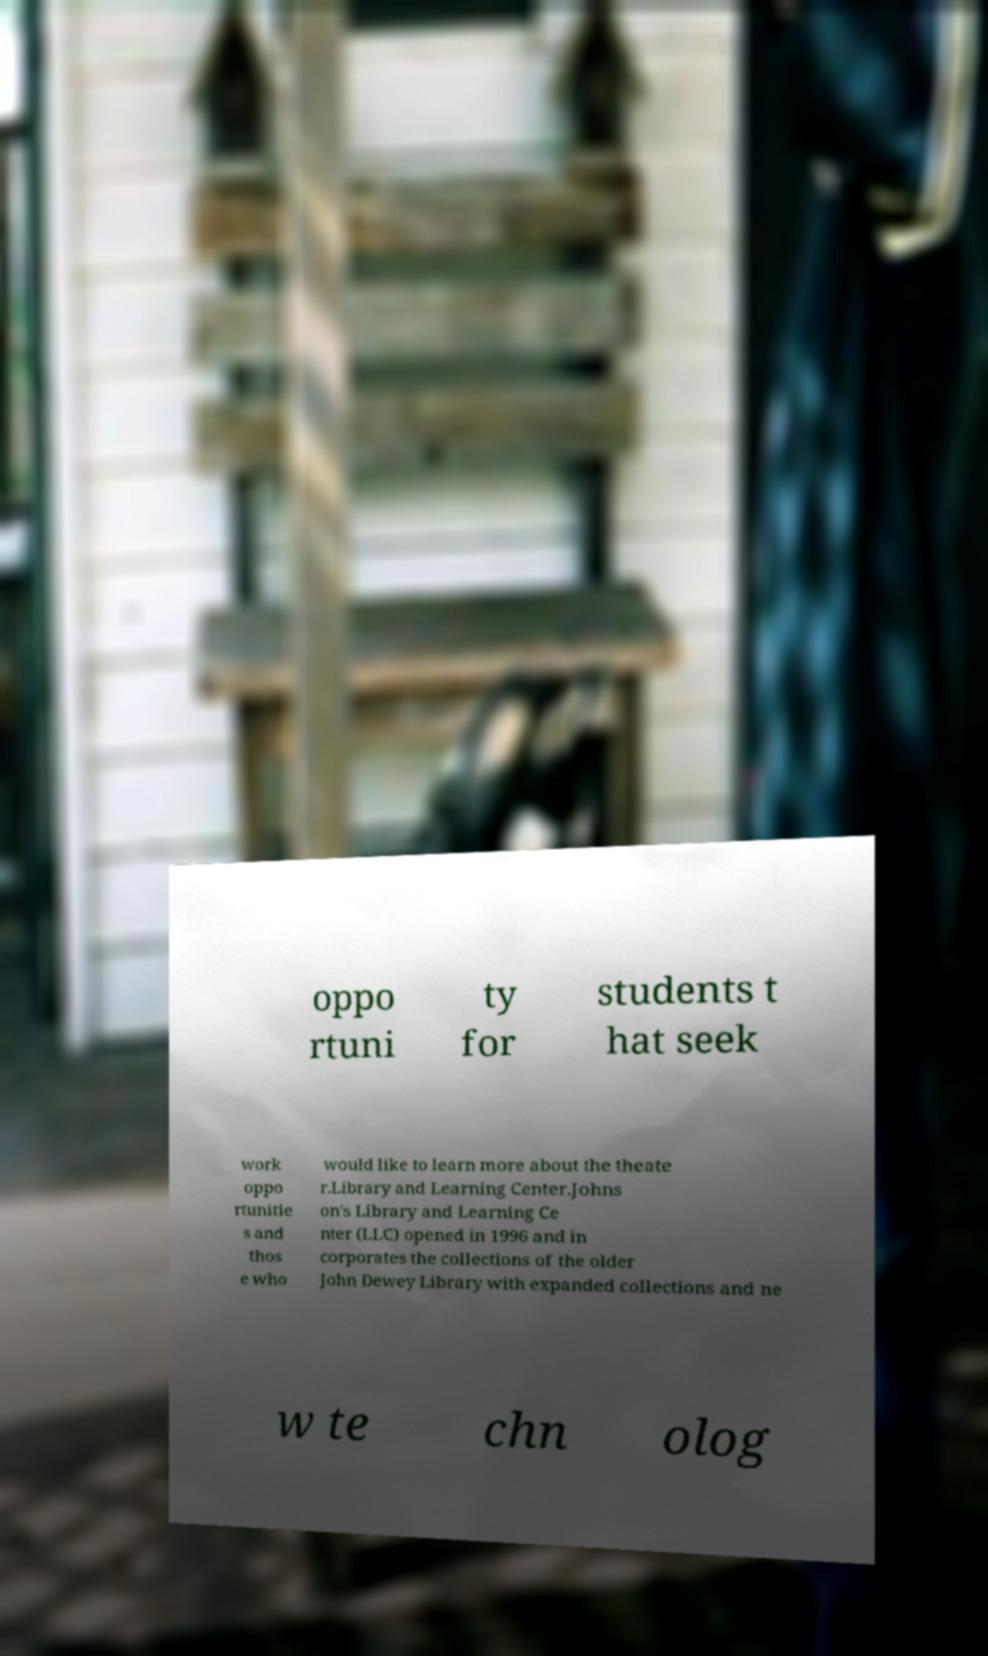For documentation purposes, I need the text within this image transcribed. Could you provide that? oppo rtuni ty for students t hat seek work oppo rtunitie s and thos e who would like to learn more about the theate r.Library and Learning Center.Johns on's Library and Learning Ce nter (LLC) opened in 1996 and in corporates the collections of the older John Dewey Library with expanded collections and ne w te chn olog 